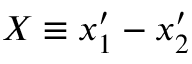<formula> <loc_0><loc_0><loc_500><loc_500>X \equiv x _ { 1 } ^ { \prime } - x _ { 2 } ^ { \prime }</formula> 